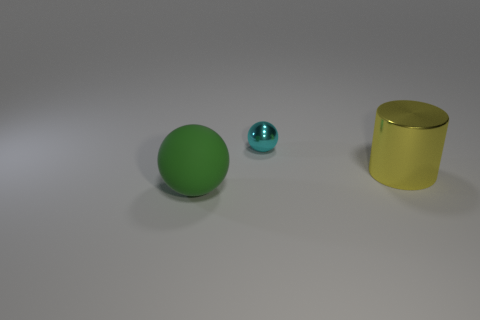Are there fewer large green matte things in front of the yellow cylinder than big things that are in front of the cyan metallic sphere?
Your answer should be very brief. Yes. The tiny thing that is made of the same material as the large yellow thing is what color?
Offer a terse response. Cyan. What is the color of the big thing to the right of the sphere that is in front of the cylinder?
Make the answer very short. Yellow. What is the shape of the matte thing that is the same size as the yellow metallic object?
Provide a short and direct response. Sphere. How many objects are right of the sphere in front of the shiny sphere?
Give a very brief answer. 2. What number of other things are made of the same material as the cyan sphere?
Your response must be concise. 1. There is a tiny metal object that is behind the big thing behind the large sphere; what is its shape?
Keep it short and to the point. Sphere. There is a ball in front of the large yellow metallic cylinder; how big is it?
Keep it short and to the point. Large. Are the cyan object and the large yellow cylinder made of the same material?
Ensure brevity in your answer.  Yes. What shape is the other yellow thing that is made of the same material as the tiny thing?
Keep it short and to the point. Cylinder. 